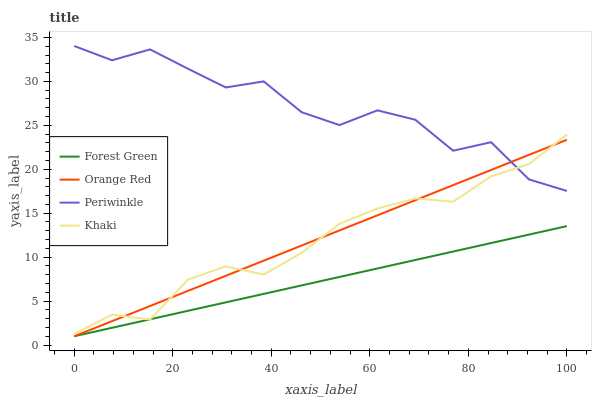Does Forest Green have the minimum area under the curve?
Answer yes or no. Yes. Does Periwinkle have the maximum area under the curve?
Answer yes or no. Yes. Does Khaki have the minimum area under the curve?
Answer yes or no. No. Does Khaki have the maximum area under the curve?
Answer yes or no. No. Is Forest Green the smoothest?
Answer yes or no. Yes. Is Periwinkle the roughest?
Answer yes or no. Yes. Is Khaki the smoothest?
Answer yes or no. No. Is Khaki the roughest?
Answer yes or no. No. Does Forest Green have the lowest value?
Answer yes or no. Yes. Does Khaki have the lowest value?
Answer yes or no. No. Does Periwinkle have the highest value?
Answer yes or no. Yes. Does Khaki have the highest value?
Answer yes or no. No. Is Forest Green less than Periwinkle?
Answer yes or no. Yes. Is Periwinkle greater than Forest Green?
Answer yes or no. Yes. Does Khaki intersect Periwinkle?
Answer yes or no. Yes. Is Khaki less than Periwinkle?
Answer yes or no. No. Is Khaki greater than Periwinkle?
Answer yes or no. No. Does Forest Green intersect Periwinkle?
Answer yes or no. No. 